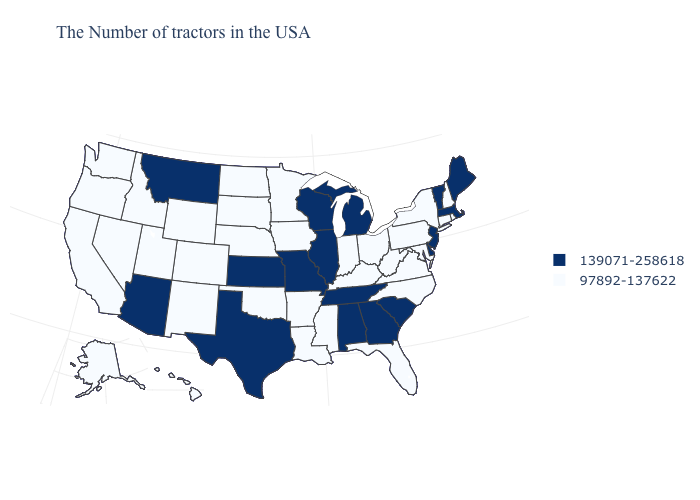Name the states that have a value in the range 97892-137622?
Short answer required. Rhode Island, New Hampshire, Connecticut, New York, Maryland, Pennsylvania, Virginia, North Carolina, West Virginia, Ohio, Florida, Kentucky, Indiana, Mississippi, Louisiana, Arkansas, Minnesota, Iowa, Nebraska, Oklahoma, South Dakota, North Dakota, Wyoming, Colorado, New Mexico, Utah, Idaho, Nevada, California, Washington, Oregon, Alaska, Hawaii. Is the legend a continuous bar?
Quick response, please. No. Does Maryland have the highest value in the USA?
Answer briefly. No. Does the first symbol in the legend represent the smallest category?
Be succinct. No. Among the states that border North Carolina , which have the highest value?
Quick response, please. South Carolina, Georgia, Tennessee. How many symbols are there in the legend?
Quick response, please. 2. What is the value of New York?
Give a very brief answer. 97892-137622. Which states have the lowest value in the West?
Short answer required. Wyoming, Colorado, New Mexico, Utah, Idaho, Nevada, California, Washington, Oregon, Alaska, Hawaii. What is the value of Wyoming?
Keep it brief. 97892-137622. What is the lowest value in states that border Texas?
Be succinct. 97892-137622. Does Tennessee have the lowest value in the USA?
Be succinct. No. Does Alabama have the lowest value in the South?
Answer briefly. No. What is the value of Arizona?
Give a very brief answer. 139071-258618. Among the states that border Maryland , which have the lowest value?
Write a very short answer. Pennsylvania, Virginia, West Virginia. Does Massachusetts have the lowest value in the Northeast?
Concise answer only. No. 